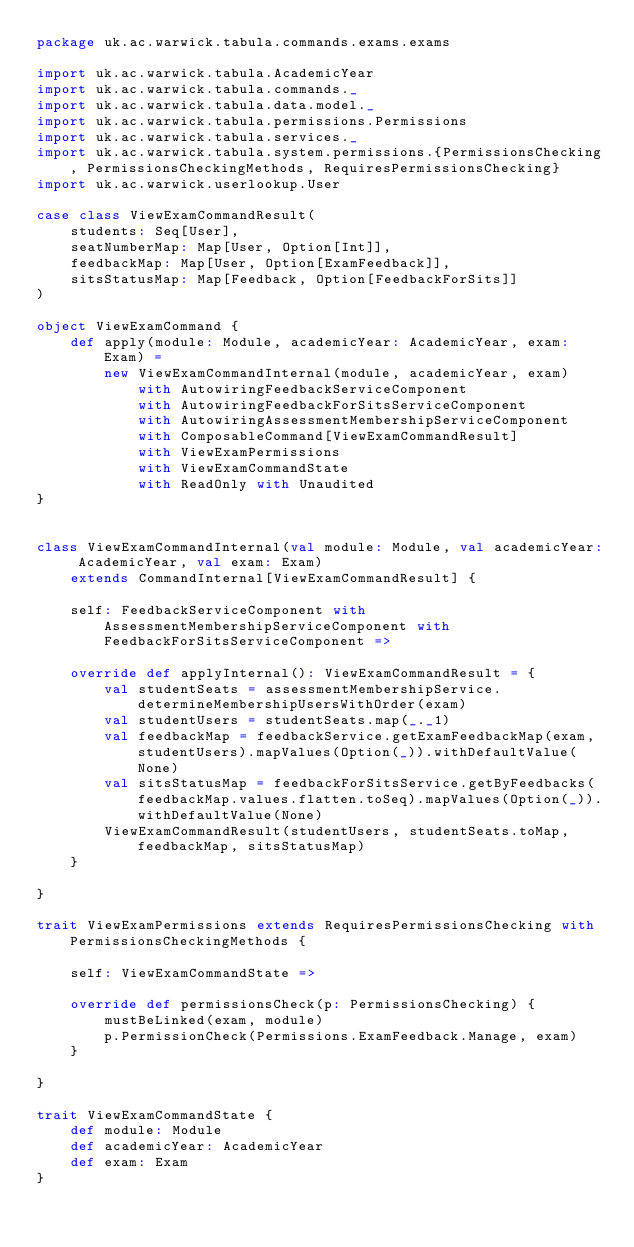<code> <loc_0><loc_0><loc_500><loc_500><_Scala_>package uk.ac.warwick.tabula.commands.exams.exams

import uk.ac.warwick.tabula.AcademicYear
import uk.ac.warwick.tabula.commands._
import uk.ac.warwick.tabula.data.model._
import uk.ac.warwick.tabula.permissions.Permissions
import uk.ac.warwick.tabula.services._
import uk.ac.warwick.tabula.system.permissions.{PermissionsChecking, PermissionsCheckingMethods, RequiresPermissionsChecking}
import uk.ac.warwick.userlookup.User

case class ViewExamCommandResult(
	students: Seq[User],
	seatNumberMap: Map[User, Option[Int]],
	feedbackMap: Map[User, Option[ExamFeedback]],
	sitsStatusMap: Map[Feedback, Option[FeedbackForSits]]
)

object ViewExamCommand {
	def apply(module: Module, academicYear: AcademicYear, exam: Exam) =
		new ViewExamCommandInternal(module, academicYear, exam)
			with AutowiringFeedbackServiceComponent
			with AutowiringFeedbackForSitsServiceComponent
			with AutowiringAssessmentMembershipServiceComponent
			with ComposableCommand[ViewExamCommandResult]
			with ViewExamPermissions
			with ViewExamCommandState
			with ReadOnly with Unaudited
}


class ViewExamCommandInternal(val module: Module, val academicYear: AcademicYear, val exam: Exam)
	extends CommandInternal[ViewExamCommandResult] {

	self: FeedbackServiceComponent with AssessmentMembershipServiceComponent with FeedbackForSitsServiceComponent =>

	override def applyInternal(): ViewExamCommandResult = {
		val studentSeats = assessmentMembershipService.determineMembershipUsersWithOrder(exam)
		val studentUsers = studentSeats.map(_._1)
		val feedbackMap = feedbackService.getExamFeedbackMap(exam, studentUsers).mapValues(Option(_)).withDefaultValue(None)
		val sitsStatusMap = feedbackForSitsService.getByFeedbacks(feedbackMap.values.flatten.toSeq).mapValues(Option(_)).withDefaultValue(None)
		ViewExamCommandResult(studentUsers, studentSeats.toMap, feedbackMap, sitsStatusMap)
	}

}

trait ViewExamPermissions extends RequiresPermissionsChecking with PermissionsCheckingMethods {

	self: ViewExamCommandState =>

	override def permissionsCheck(p: PermissionsChecking) {
		mustBeLinked(exam, module)
		p.PermissionCheck(Permissions.ExamFeedback.Manage, exam)
	}

}

trait ViewExamCommandState {
	def module: Module
	def academicYear: AcademicYear
	def exam: Exam
}
</code> 